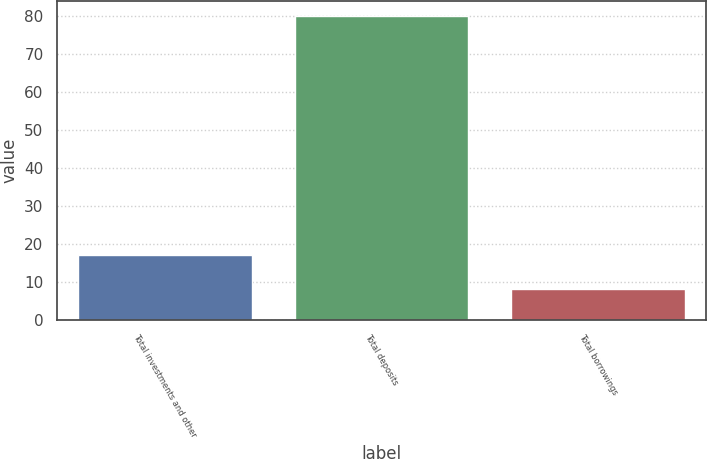Convert chart to OTSL. <chart><loc_0><loc_0><loc_500><loc_500><bar_chart><fcel>Total investments and other<fcel>Total deposits<fcel>Total borrowings<nl><fcel>17<fcel>80<fcel>8<nl></chart> 